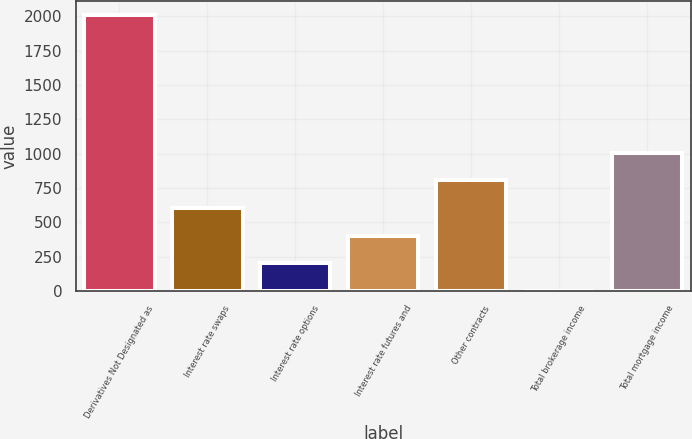Convert chart. <chart><loc_0><loc_0><loc_500><loc_500><bar_chart><fcel>Derivatives Not Designated as<fcel>Interest rate swaps<fcel>Interest rate options<fcel>Interest rate futures and<fcel>Other contracts<fcel>Total brokerage income<fcel>Total mortgage income<nl><fcel>2010<fcel>603.7<fcel>201.9<fcel>402.8<fcel>804.6<fcel>1<fcel>1005.5<nl></chart> 